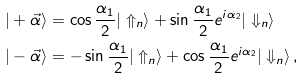<formula> <loc_0><loc_0><loc_500><loc_500>| + \vec { \alpha } \rangle & = \cos \frac { \alpha _ { 1 } } { 2 } | \Uparrow _ { n } \rangle + \sin \frac { \alpha _ { 1 } } { 2 } e ^ { i \alpha _ { 2 } } | \Downarrow _ { n } \rangle \\ | - \vec { \alpha } \rangle & = - \sin \frac { \alpha _ { 1 } } { 2 } | \Uparrow _ { n } \rangle + \cos \frac { \alpha _ { 1 } } { 2 } e ^ { i \alpha _ { 2 } } | \Downarrow _ { n } \rangle \, ,</formula> 